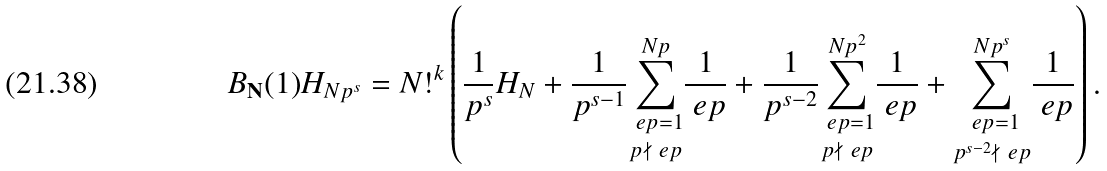Convert formula to latex. <formula><loc_0><loc_0><loc_500><loc_500>B _ { \mathbf N } ( 1 ) H _ { N p ^ { s } } & = N ! ^ { k } \left ( \frac { 1 } { p ^ { s } } H _ { N } + \frac { 1 } { p ^ { s - 1 } } \underset { p \nmid \ e p } { \sum _ { \ e p = 1 } ^ { N p } } \frac { 1 } { \ e p } + \frac { 1 } { p ^ { s - 2 } } \underset { p \nmid \ e p } { \sum _ { \ e p = 1 } ^ { N p ^ { 2 } } } \frac { 1 } { \ e p } + \underset { p ^ { s - 2 } \nmid \ e p } { \sum _ { \ e p = 1 } ^ { N p ^ { s } } } \frac { 1 } { \ e p } \right ) .</formula> 